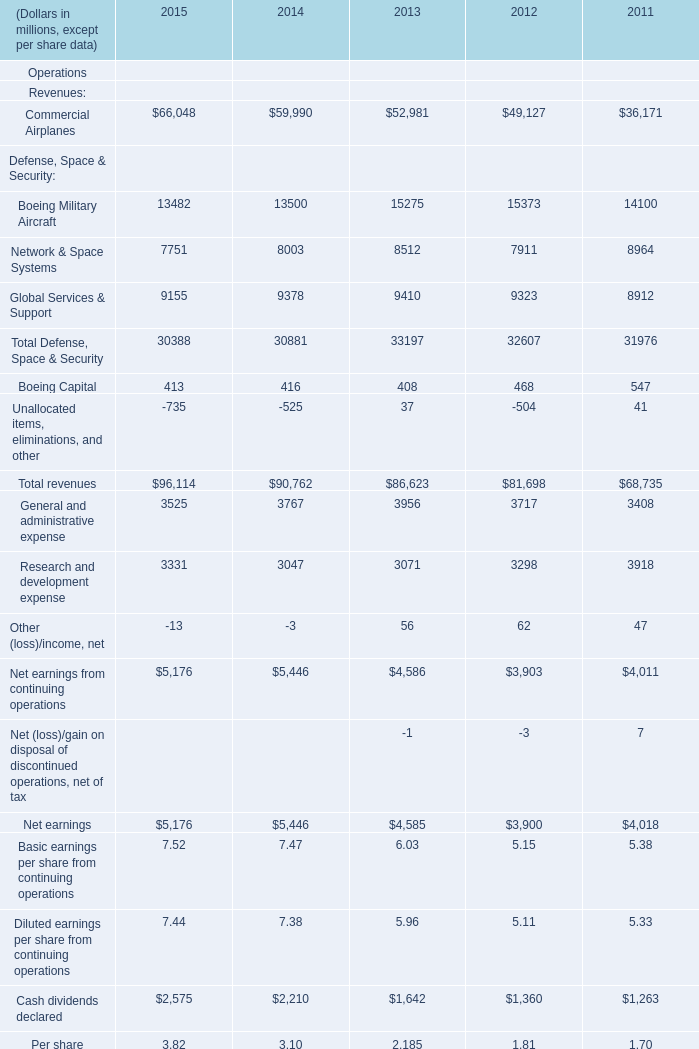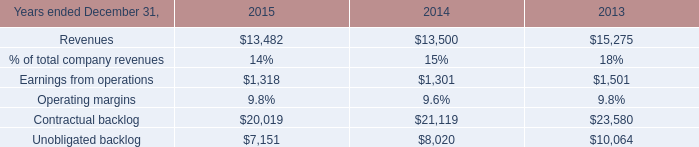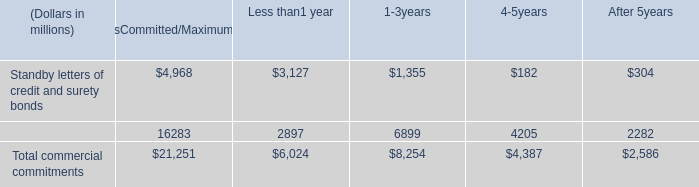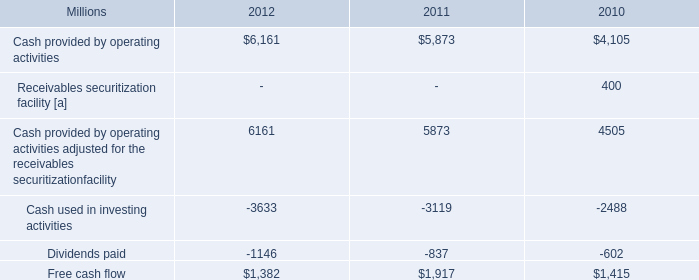What's the total amount of Boeing Military Aircraft and Boeing Military Aircraftin the range of 13000 and 15000 in all year? (in million) 
Computations: (8512 + 15275)
Answer: 23787.0. 